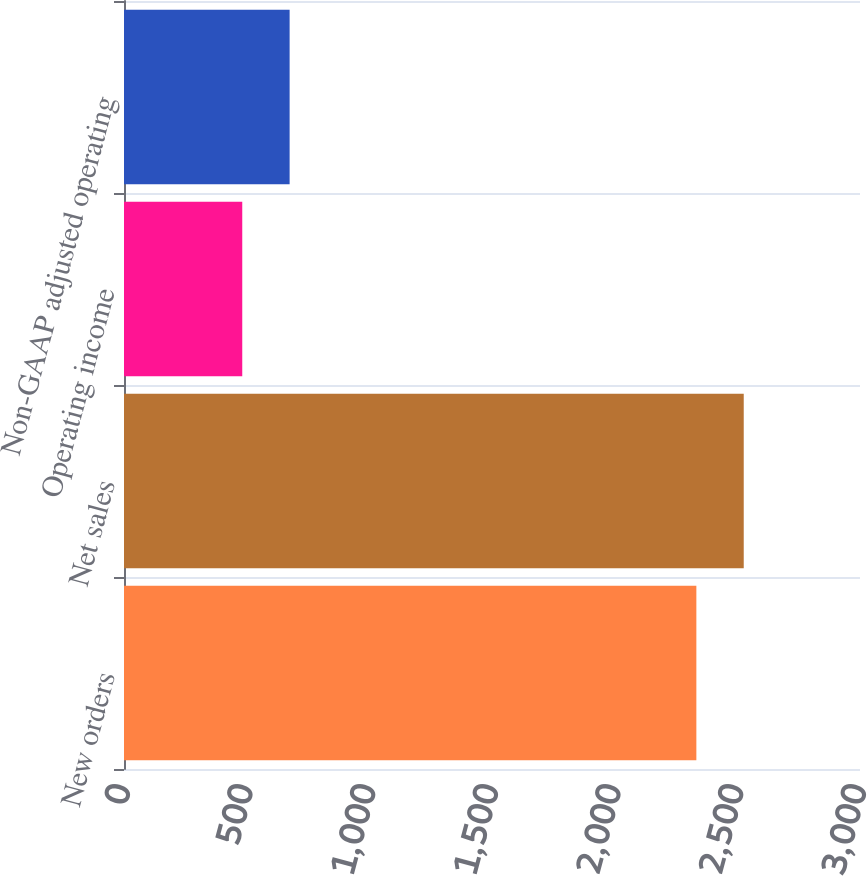Convert chart to OTSL. <chart><loc_0><loc_0><loc_500><loc_500><bar_chart><fcel>New orders<fcel>Net sales<fcel>Operating income<fcel>Non-GAAP adjusted operating<nl><fcel>2333<fcel>2526.1<fcel>482<fcel>675.1<nl></chart> 